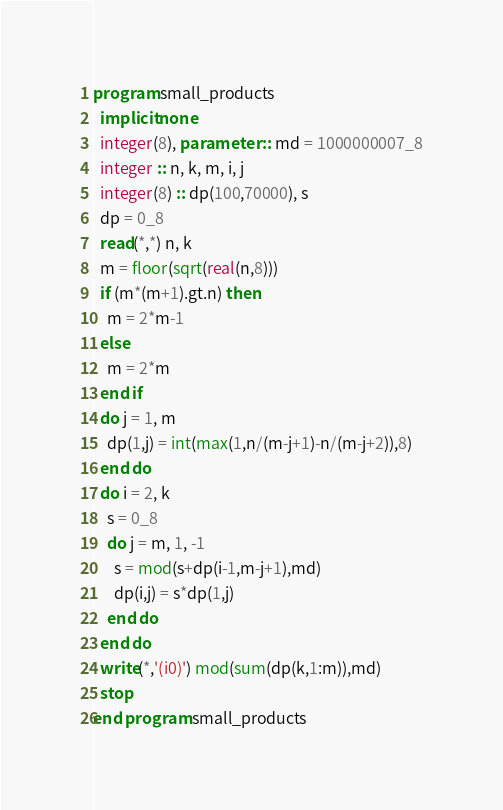Convert code to text. <code><loc_0><loc_0><loc_500><loc_500><_FORTRAN_>program small_products
  implicit none
  integer(8), parameter :: md = 1000000007_8
  integer :: n, k, m, i, j
  integer(8) :: dp(100,70000), s
  dp = 0_8
  read(*,*) n, k
  m = floor(sqrt(real(n,8)))
  if (m*(m+1).gt.n) then
    m = 2*m-1
  else
    m = 2*m
  end if
  do j = 1, m
    dp(1,j) = int(max(1,n/(m-j+1)-n/(m-j+2)),8)
  end do
  do i = 2, k
    s = 0_8
    do j = m, 1, -1
      s = mod(s+dp(i-1,m-j+1),md)
      dp(i,j) = s*dp(1,j)
    end do
  end do
  write(*,'(i0)') mod(sum(dp(k,1:m)),md)
  stop
end program small_products</code> 